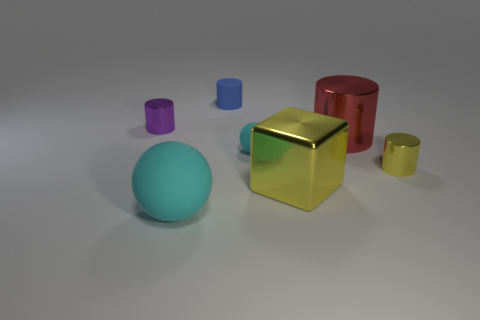Can you describe how the light source in the image affects the appearance of the objects? The light source in the image appears to be located above and slightly to the right of the objects, casting soft shadows to their left. This lighting accentuates their three-dimensional form and brings out the reflective quality of their surfaces, particularly noticeable on the golden cube and the red cylinder. 